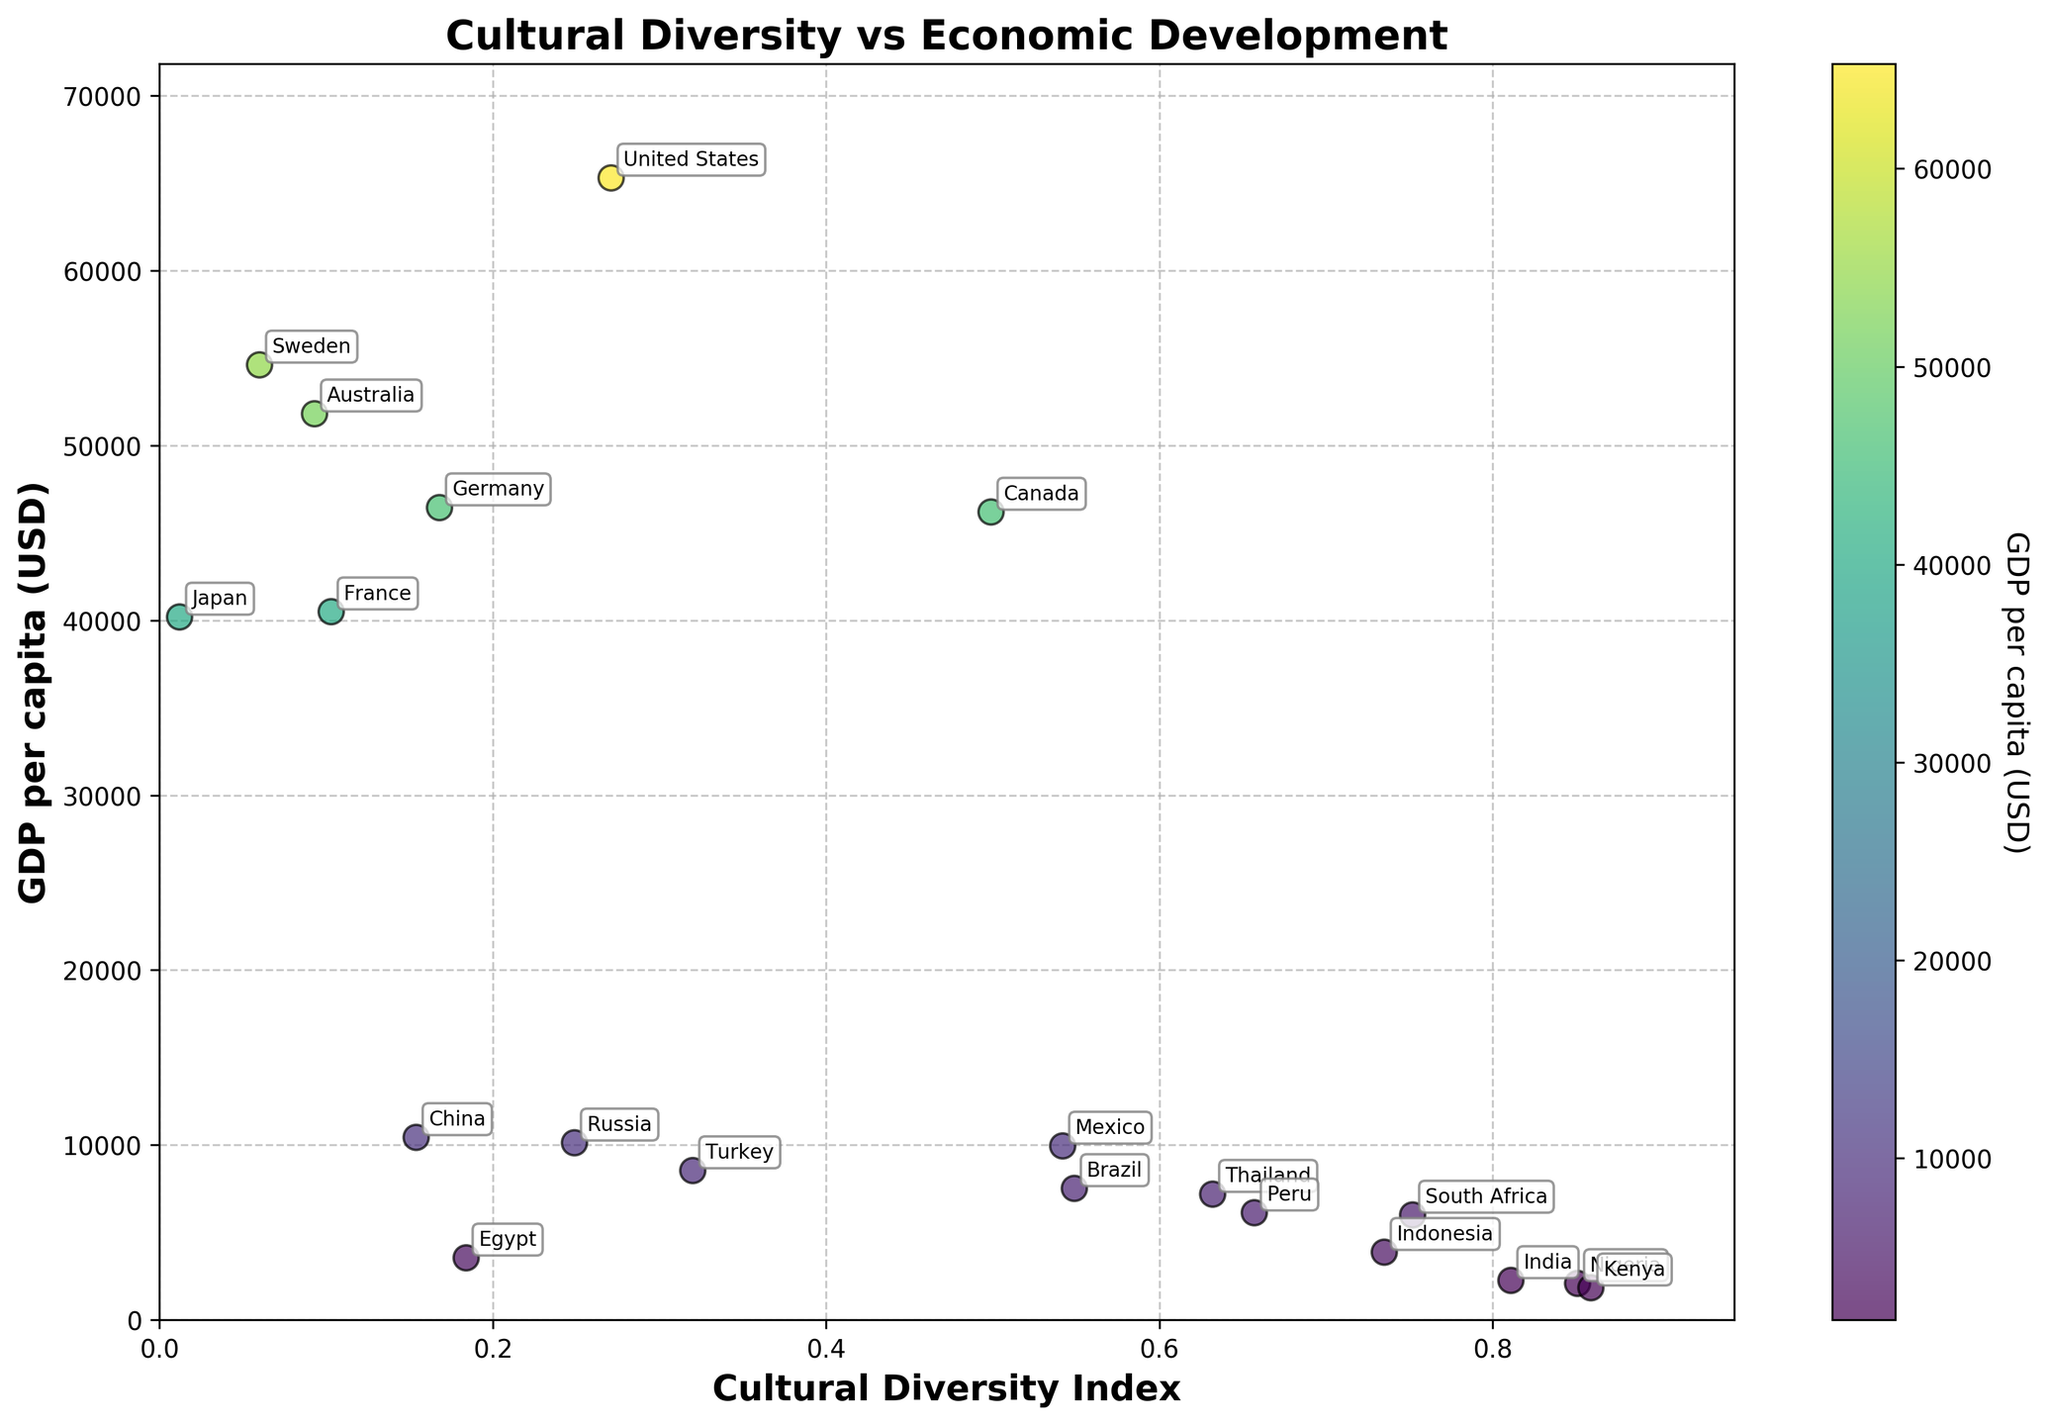What is the title of the plot? The plot's title is clearly visible at the top of the figure. It reads "Cultural Diversity vs Economic Development".
Answer: Cultural Diversity vs Economic Development How many countries are included in the plot? By counting the number of unique points or annotations in the scatter plot, we can determine the number of countries. Each point is associated with a country name.
Answer: 20 Which country has the highest Cultural Diversity Index? By locating the point farthest to the right along the x-axis, we find that Kenya has the highest Cultural Diversity Index.
Answer: Kenya Which country has the lowest GDP per capita? By identifying the point nearest to the bottom of the y-axis, it is evident that Kenya has the lowest GDP per capita.
Answer: Kenya Which two countries have a similar Cultural Diversity Index but different GDP per capita? By examining the clusters of points along the x-axis, we can see that Indonesia and South Africa have similar Cultural Diversity Indices but differ significantly in GDP per capita.
Answer: Indonesia and South Africa What is the GDP per capita of the United States? The point labeled "United States" is located at a GDP per capita of around 65297 based on its position along the y-axis.
Answer: 65297 What can be inferred about the relationship between Cultural Diversity Index and GDP per capita from the plot? Observing the general distribution of points, it’s apparent that there is no strong linear relationship between Cultural Diversity Index and GDP per capita; countries with higher diversity do not necessarily have higher or lower GDP per capita.
Answer: No strong relationship Which country has the lowest Cultural Diversity Index? By finding the point farthest to the left on the x-axis, Japan is determined to have the lowest Cultural Diversity Index.
Answer: Japan Compare the GDP per capita of Canada and Germany. Which one is higher and by how much? We locate the points for Canada and Germany on the y-axis. Canada’s GDP per capita is 46195 and Germany’s is 46445. Germany’s GDP per capita is higher by 250.
Answer: Germany by 250 What color represents the highest GDP per capita on the scatter plot, and which country's data point is this color? The color bar indicates that the darkest shade represents the highest GDP per capita. The United States has this color, indicating its high value.
Answer: Darkest shade, United States 